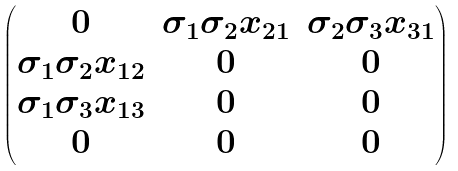Convert formula to latex. <formula><loc_0><loc_0><loc_500><loc_500>\begin{pmatrix} 0 & \sigma _ { 1 } \sigma _ { 2 } x _ { 2 1 } & \sigma _ { 2 } \sigma _ { 3 } x _ { 3 1 } \\ \sigma _ { 1 } \sigma _ { 2 } x _ { 1 2 } & 0 & 0 \\ \sigma _ { 1 } \sigma _ { 3 } x _ { 1 3 } & 0 & 0 \\ 0 & 0 & 0 \end{pmatrix}</formula> 